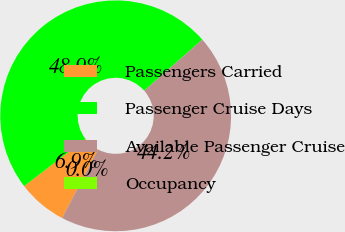Convert chart. <chart><loc_0><loc_0><loc_500><loc_500><pie_chart><fcel>Passengers Carried<fcel>Passenger Cruise Days<fcel>Available Passenger Cruise<fcel>Occupancy<nl><fcel>6.9%<fcel>48.94%<fcel>44.16%<fcel>0.0%<nl></chart> 